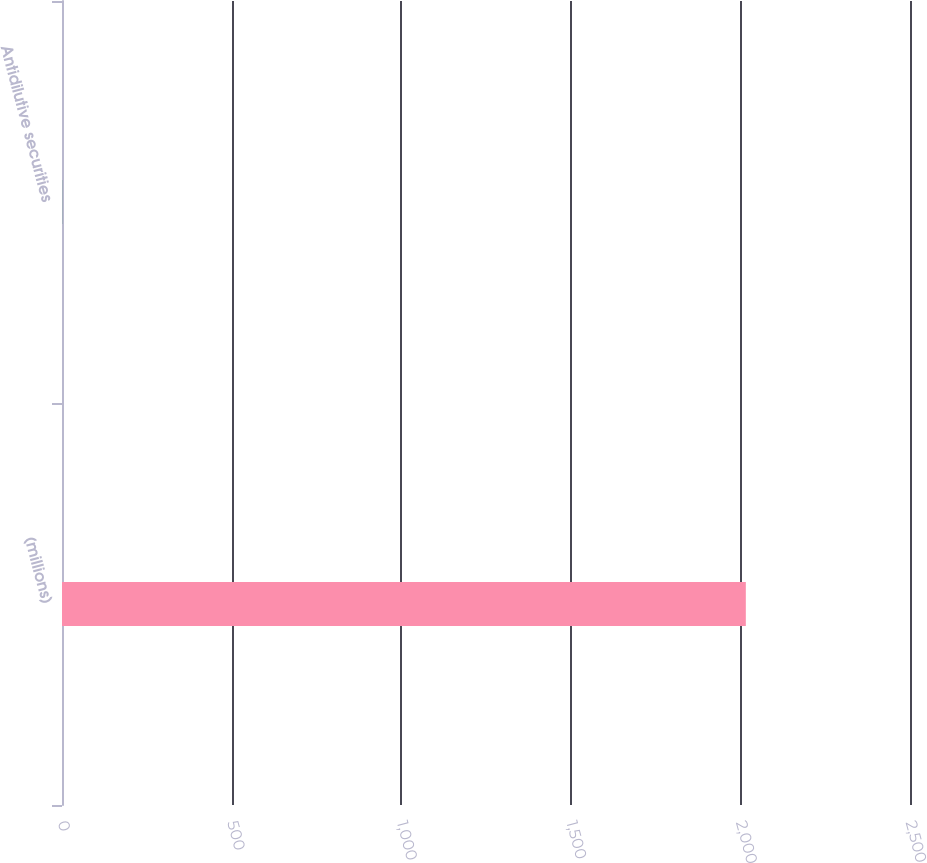Convert chart. <chart><loc_0><loc_0><loc_500><loc_500><bar_chart><fcel>(millions)<fcel>Antidilutive securities<nl><fcel>2016<fcel>0.5<nl></chart> 